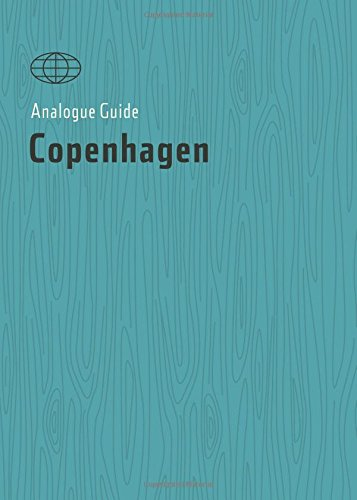What kind of sights or experiences does the book suggest exploring in Copenhagen? The guide is filled with recommendations for unique, often overlooked attractions and local favorites, from cozy cafes to historical landmarks. 